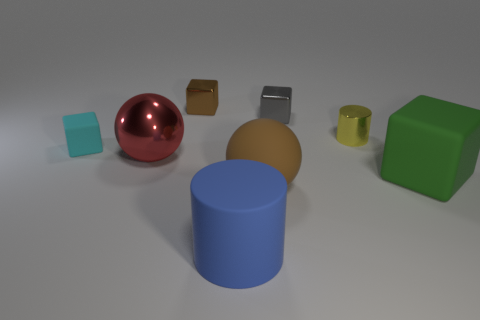Subtract all gray cylinders. Subtract all blue spheres. How many cylinders are left? 2 Subtract all blue cylinders. How many purple cubes are left? 0 Add 8 tiny browns. How many tiny cyans exist? 0 Subtract all tiny yellow metallic objects. Subtract all tiny objects. How many objects are left? 3 Add 8 big green things. How many big green things are left? 9 Add 6 cyan rubber cubes. How many cyan rubber cubes exist? 7 Add 1 matte cylinders. How many objects exist? 9 Subtract all cyan cubes. How many cubes are left? 3 Subtract all small brown shiny blocks. How many blocks are left? 3 Subtract 1 brown spheres. How many objects are left? 7 